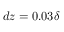Convert formula to latex. <formula><loc_0><loc_0><loc_500><loc_500>d z = 0 . 0 3 \delta</formula> 